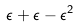<formula> <loc_0><loc_0><loc_500><loc_500>\epsilon + \epsilon - \epsilon ^ { 2 }</formula> 